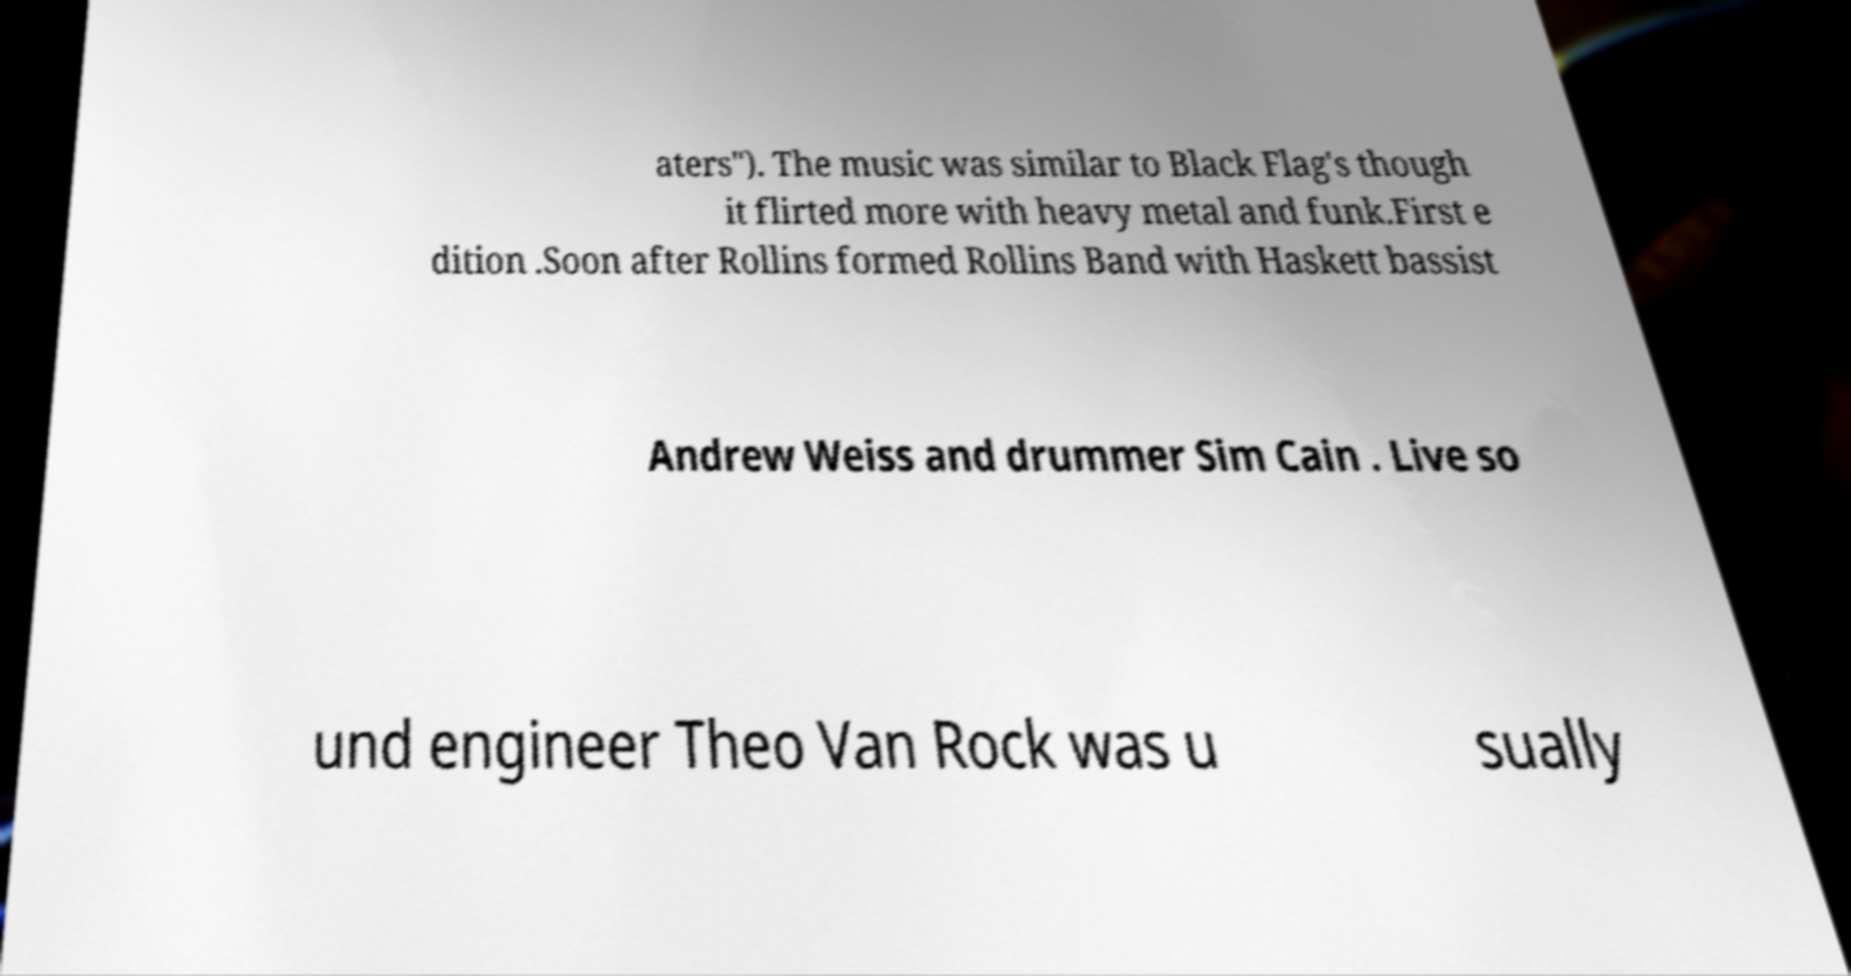Can you read and provide the text displayed in the image?This photo seems to have some interesting text. Can you extract and type it out for me? aters"). The music was similar to Black Flag's though it flirted more with heavy metal and funk.First e dition .Soon after Rollins formed Rollins Band with Haskett bassist Andrew Weiss and drummer Sim Cain . Live so und engineer Theo Van Rock was u sually 